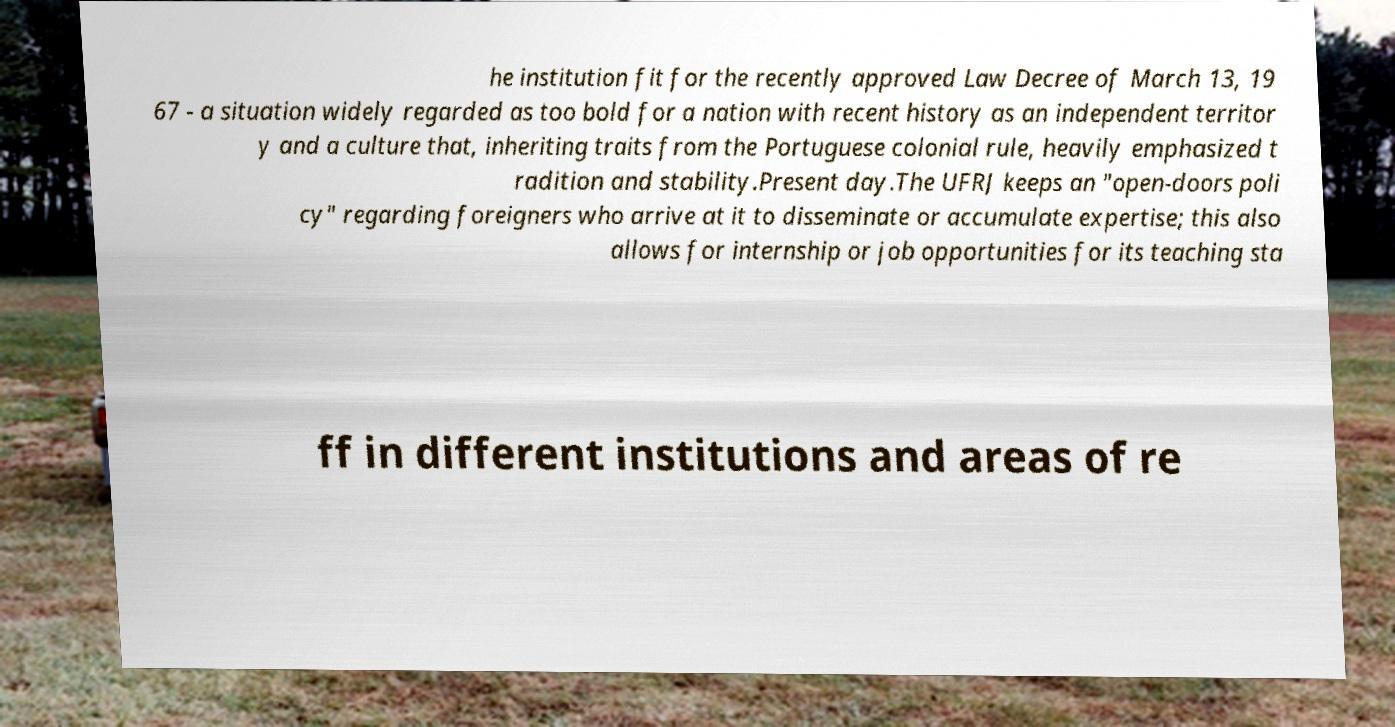I need the written content from this picture converted into text. Can you do that? he institution fit for the recently approved Law Decree of March 13, 19 67 - a situation widely regarded as too bold for a nation with recent history as an independent territor y and a culture that, inheriting traits from the Portuguese colonial rule, heavily emphasized t radition and stability.Present day.The UFRJ keeps an "open-doors poli cy" regarding foreigners who arrive at it to disseminate or accumulate expertise; this also allows for internship or job opportunities for its teaching sta ff in different institutions and areas of re 